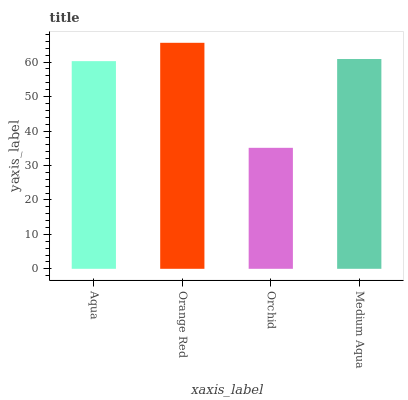Is Orchid the minimum?
Answer yes or no. Yes. Is Orange Red the maximum?
Answer yes or no. Yes. Is Orange Red the minimum?
Answer yes or no. No. Is Orchid the maximum?
Answer yes or no. No. Is Orange Red greater than Orchid?
Answer yes or no. Yes. Is Orchid less than Orange Red?
Answer yes or no. Yes. Is Orchid greater than Orange Red?
Answer yes or no. No. Is Orange Red less than Orchid?
Answer yes or no. No. Is Medium Aqua the high median?
Answer yes or no. Yes. Is Aqua the low median?
Answer yes or no. Yes. Is Aqua the high median?
Answer yes or no. No. Is Orange Red the low median?
Answer yes or no. No. 